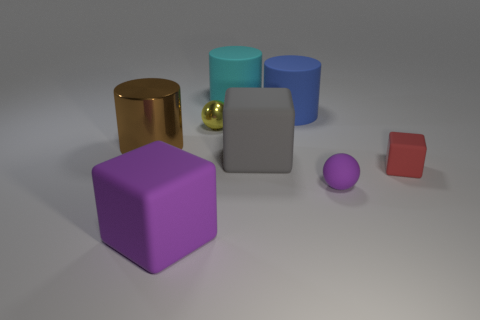Add 1 blue things. How many objects exist? 9 Subtract all cubes. How many objects are left? 5 Add 4 purple matte things. How many purple matte things are left? 6 Add 3 big shiny cylinders. How many big shiny cylinders exist? 4 Subtract 1 red blocks. How many objects are left? 7 Subtract all matte cylinders. Subtract all tiny red cubes. How many objects are left? 5 